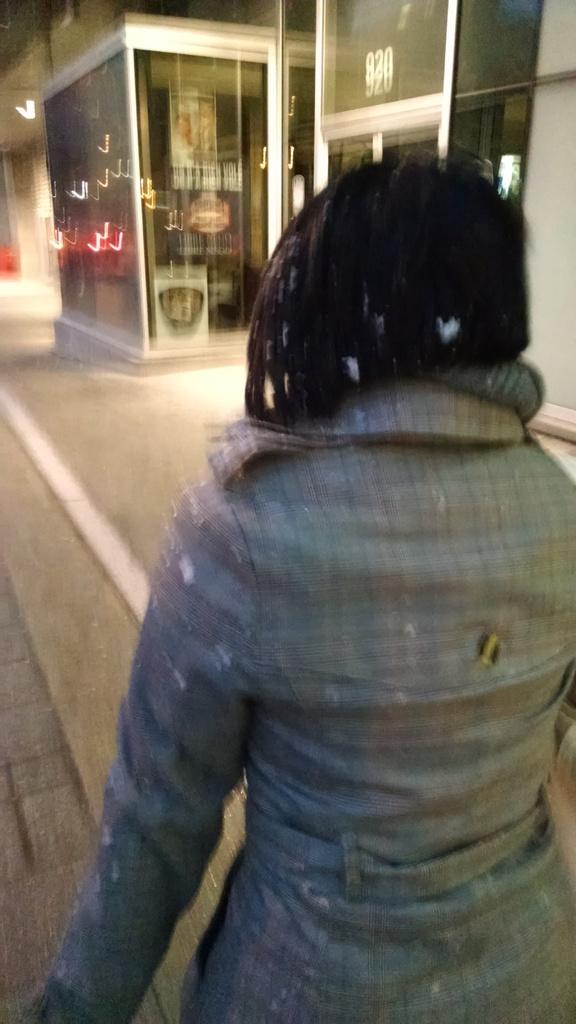Who is present in the image? There is a woman in the image. What type of establishment can be seen in the image? There is a store with objects in the image. What other structure is visible in the image? There is a building in the image. What type of spade is the woman using to dig in the image? There is no spade present in the image. How does the woman express her feelings towards the bike in the image? There is no bike present in the image, so it is not possible to determine how the woman feels about it. 